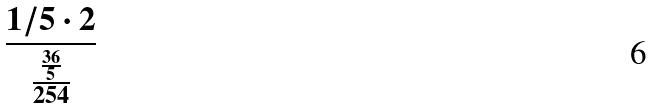<formula> <loc_0><loc_0><loc_500><loc_500>\frac { 1 / 5 \cdot 2 } { \frac { \frac { 3 6 } { 5 } } { 2 5 4 } }</formula> 